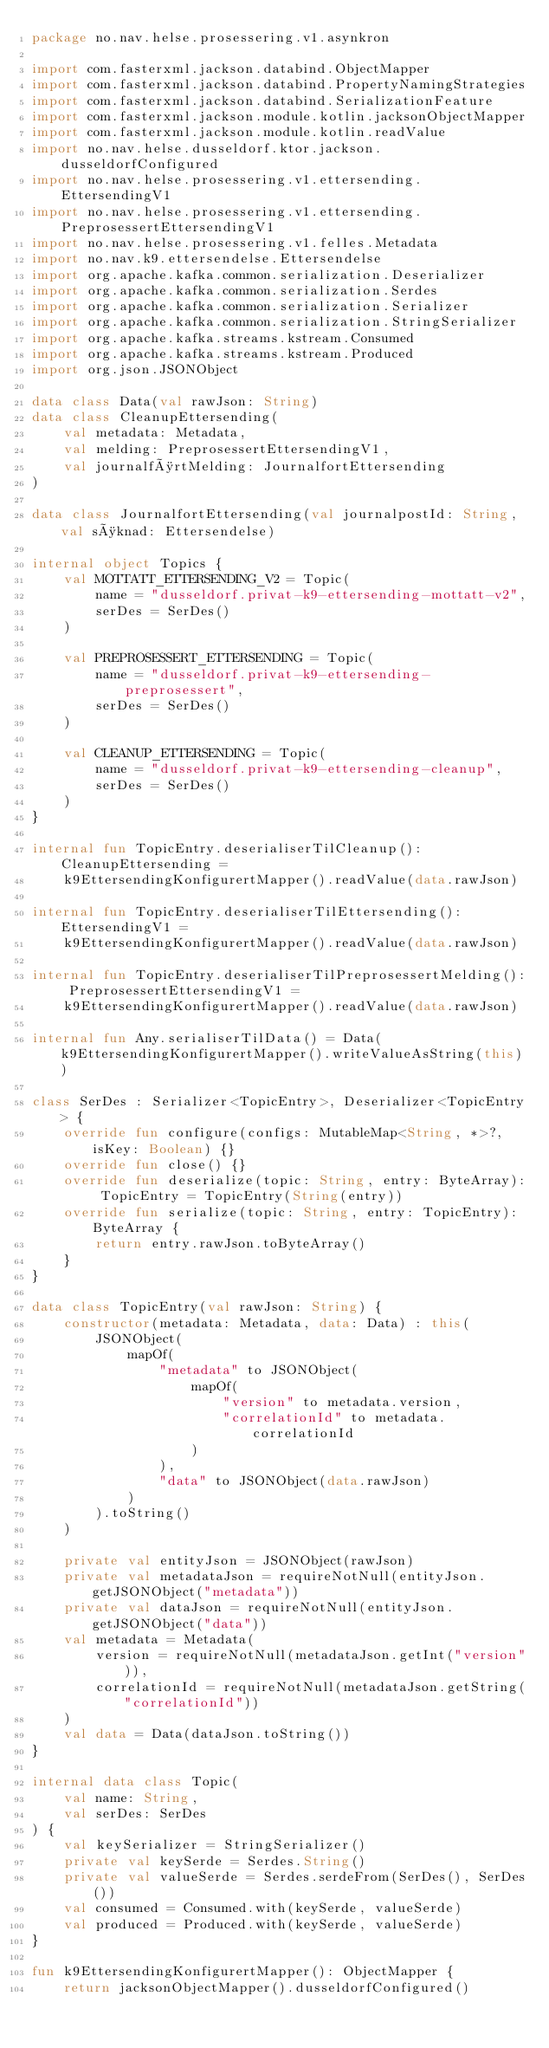<code> <loc_0><loc_0><loc_500><loc_500><_Kotlin_>package no.nav.helse.prosessering.v1.asynkron

import com.fasterxml.jackson.databind.ObjectMapper
import com.fasterxml.jackson.databind.PropertyNamingStrategies
import com.fasterxml.jackson.databind.SerializationFeature
import com.fasterxml.jackson.module.kotlin.jacksonObjectMapper
import com.fasterxml.jackson.module.kotlin.readValue
import no.nav.helse.dusseldorf.ktor.jackson.dusseldorfConfigured
import no.nav.helse.prosessering.v1.ettersending.EttersendingV1
import no.nav.helse.prosessering.v1.ettersending.PreprosessertEttersendingV1
import no.nav.helse.prosessering.v1.felles.Metadata
import no.nav.k9.ettersendelse.Ettersendelse
import org.apache.kafka.common.serialization.Deserializer
import org.apache.kafka.common.serialization.Serdes
import org.apache.kafka.common.serialization.Serializer
import org.apache.kafka.common.serialization.StringSerializer
import org.apache.kafka.streams.kstream.Consumed
import org.apache.kafka.streams.kstream.Produced
import org.json.JSONObject

data class Data(val rawJson: String)
data class CleanupEttersending(
    val metadata: Metadata,
    val melding: PreprosessertEttersendingV1,
    val journalførtMelding: JournalfortEttersending
)

data class JournalfortEttersending(val journalpostId: String, val søknad: Ettersendelse)

internal object Topics {
    val MOTTATT_ETTERSENDING_V2 = Topic(
        name = "dusseldorf.privat-k9-ettersending-mottatt-v2",
        serDes = SerDes()
    )

    val PREPROSESSERT_ETTERSENDING = Topic(
        name = "dusseldorf.privat-k9-ettersending-preprosessert",
        serDes = SerDes()
    )

    val CLEANUP_ETTERSENDING = Topic(
        name = "dusseldorf.privat-k9-ettersending-cleanup",
        serDes = SerDes()
    )
}

internal fun TopicEntry.deserialiserTilCleanup(): CleanupEttersending =
    k9EttersendingKonfigurertMapper().readValue(data.rawJson)

internal fun TopicEntry.deserialiserTilEttersending(): EttersendingV1 =
    k9EttersendingKonfigurertMapper().readValue(data.rawJson)

internal fun TopicEntry.deserialiserTilPreprosessertMelding(): PreprosessertEttersendingV1 =
    k9EttersendingKonfigurertMapper().readValue(data.rawJson)

internal fun Any.serialiserTilData() = Data(k9EttersendingKonfigurertMapper().writeValueAsString(this))

class SerDes : Serializer<TopicEntry>, Deserializer<TopicEntry> {
    override fun configure(configs: MutableMap<String, *>?, isKey: Boolean) {}
    override fun close() {}
    override fun deserialize(topic: String, entry: ByteArray): TopicEntry = TopicEntry(String(entry))
    override fun serialize(topic: String, entry: TopicEntry): ByteArray {
        return entry.rawJson.toByteArray()
    }
}

data class TopicEntry(val rawJson: String) {
    constructor(metadata: Metadata, data: Data) : this(
        JSONObject(
            mapOf(
                "metadata" to JSONObject(
                    mapOf(
                        "version" to metadata.version,
                        "correlationId" to metadata.correlationId
                    )
                ),
                "data" to JSONObject(data.rawJson)
            )
        ).toString()
    )

    private val entityJson = JSONObject(rawJson)
    private val metadataJson = requireNotNull(entityJson.getJSONObject("metadata"))
    private val dataJson = requireNotNull(entityJson.getJSONObject("data"))
    val metadata = Metadata(
        version = requireNotNull(metadataJson.getInt("version")),
        correlationId = requireNotNull(metadataJson.getString("correlationId"))
    )
    val data = Data(dataJson.toString())
}

internal data class Topic(
    val name: String,
    val serDes: SerDes
) {
    val keySerializer = StringSerializer()
    private val keySerde = Serdes.String()
    private val valueSerde = Serdes.serdeFrom(SerDes(), SerDes())
    val consumed = Consumed.with(keySerde, valueSerde)
    val produced = Produced.with(keySerde, valueSerde)
}

fun k9EttersendingKonfigurertMapper(): ObjectMapper {
    return jacksonObjectMapper().dusseldorfConfigured()</code> 